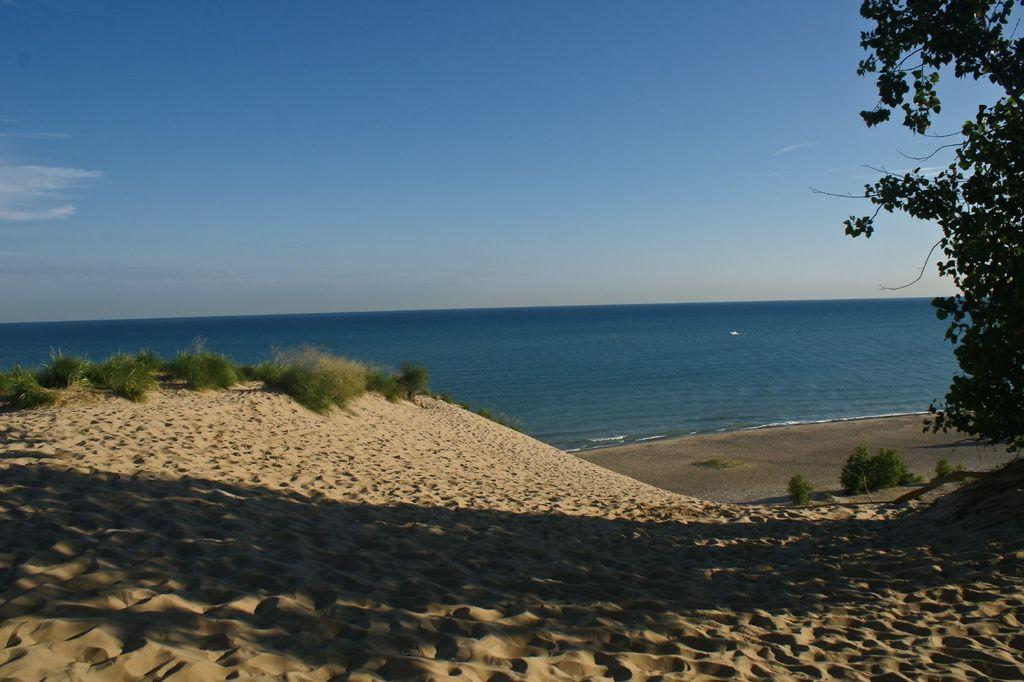What type of vegetation is present on the sand surface in the image? There is grass on the sand surface of the ground in the image. What can be seen on the right side of the image? There is a tree on the right side of the image. What other types of vegetation are visible in the image? There are plants in the image. What is visible in the background of the image? There is an ocean and clouds in the blue sky in the background of the image. How much money is being exchanged between the clouds and the ocean in the image? There is no exchange of money between the clouds and the ocean in the image, as they are natural elements and not involved in financial transactions. 